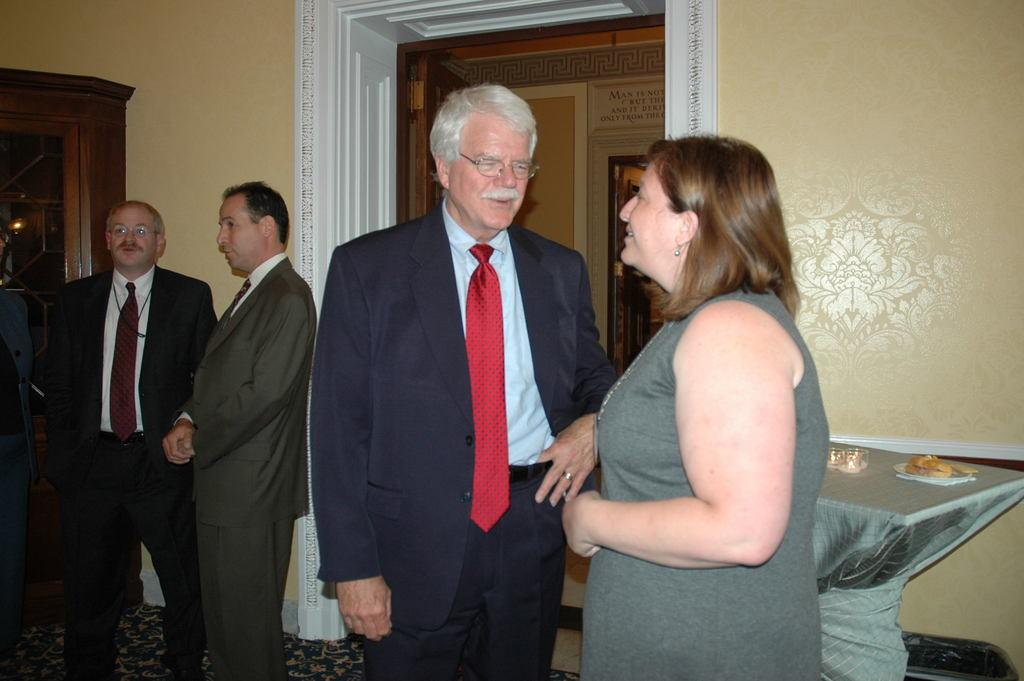What are the people in the image doing? The people in the image are standing and talking. What can be seen on the table in the image? There are objects placed on the table. Can you describe the door visible in the image? The door is visible in the image and is connected to a wall. What trail can be seen in the image? There is no trail present in the image. 